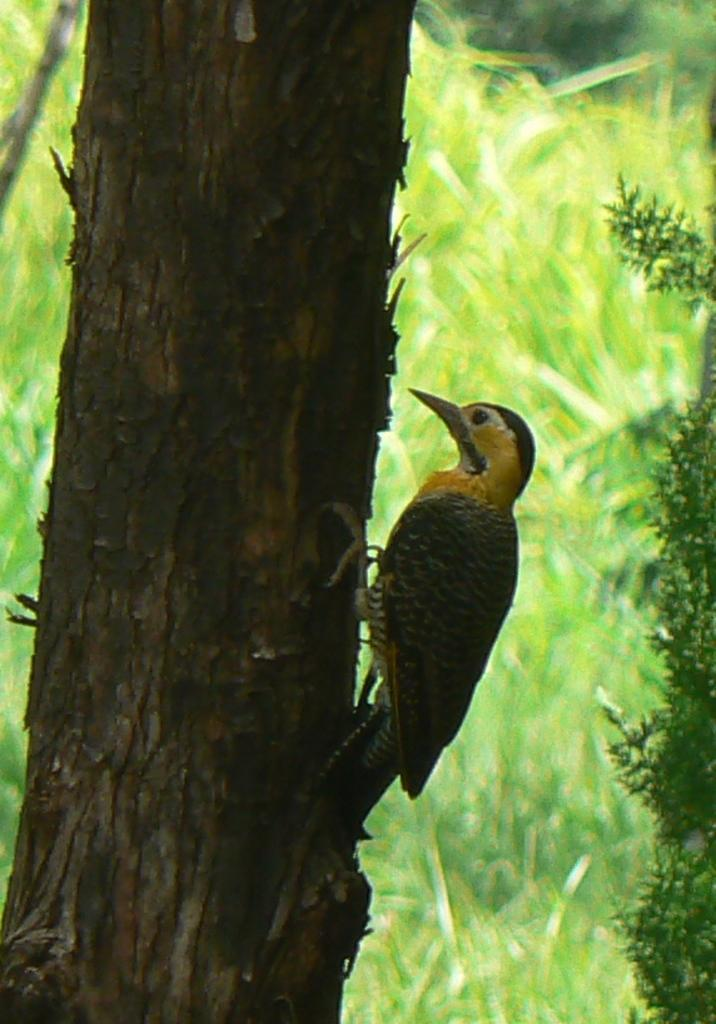What type of animal is in the image? There is a bird in the image. Where is the bird located? The bird is on a branch. What colors can be seen on the bird? The bird has black, yellow, and white colors. What can be seen in the background of the image? There are many trees in the background of the image. What type of airport can be seen in the image? There is no airport present in the image; it features a bird on a branch with trees in the background. How many boats are visible in the image? There are no boats visible in the image. 